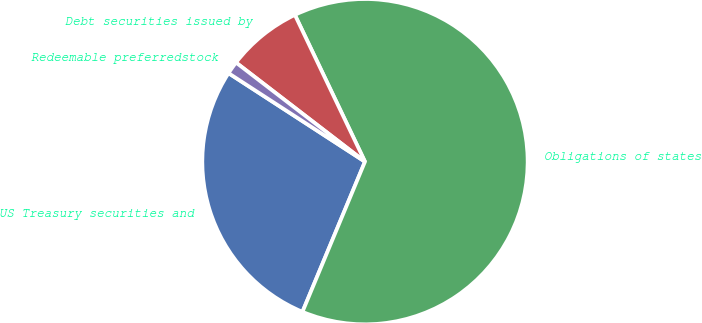Convert chart. <chart><loc_0><loc_0><loc_500><loc_500><pie_chart><fcel>US Treasury securities and<fcel>Obligations of states<fcel>Debt securities issued by<fcel>Redeemable preferredstock<nl><fcel>27.88%<fcel>63.37%<fcel>7.48%<fcel>1.27%<nl></chart> 